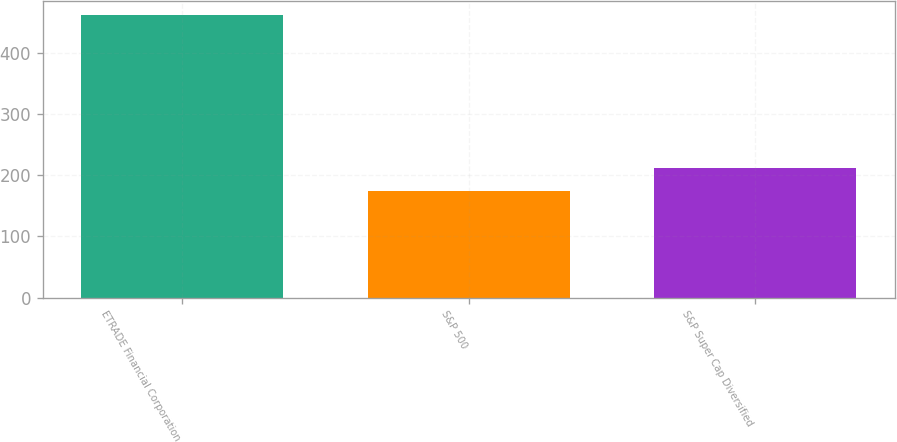Convert chart to OTSL. <chart><loc_0><loc_0><loc_500><loc_500><bar_chart><fcel>ETRADE Financial Corporation<fcel>S&P 500<fcel>S&P Super Cap Diversified<nl><fcel>461.32<fcel>173.34<fcel>211.13<nl></chart> 